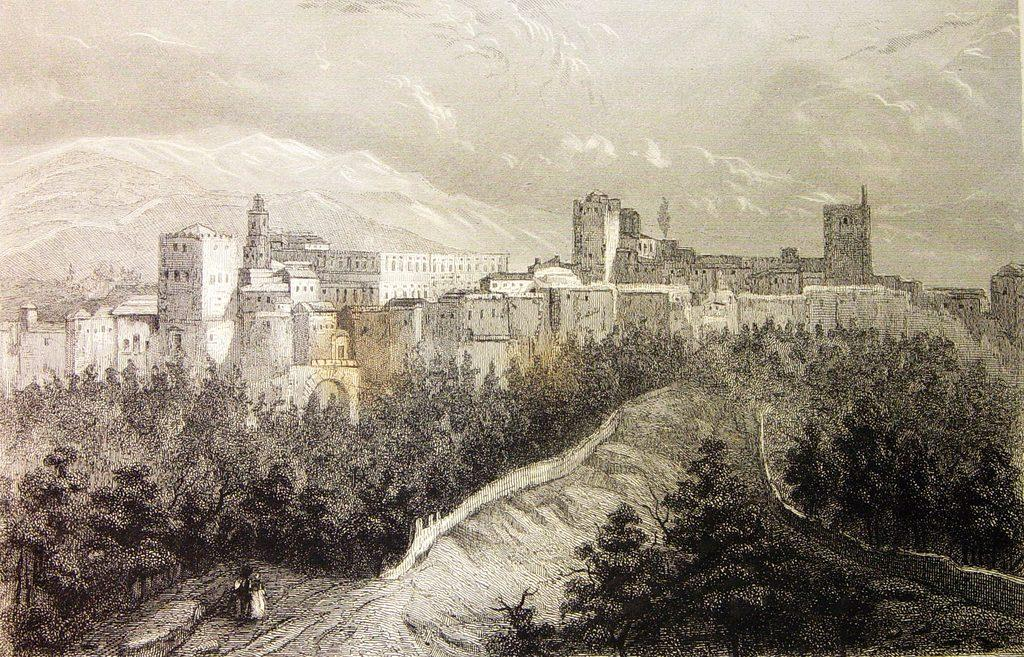What type of image is depicted? The image is a sketch. What type of flower is being protested in the image? There is no flower or protest present in the image, as it is a sketch without any specific subject matter. 